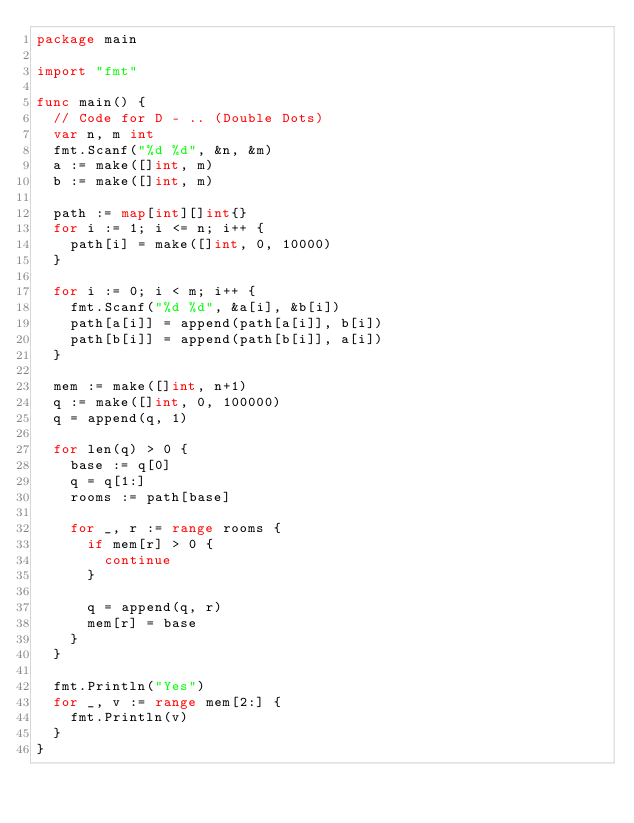Convert code to text. <code><loc_0><loc_0><loc_500><loc_500><_Go_>package main

import "fmt"

func main() {
	// Code for D - .. (Double Dots)
	var n, m int
	fmt.Scanf("%d %d", &n, &m)
	a := make([]int, m)
	b := make([]int, m)

	path := map[int][]int{}
	for i := 1; i <= n; i++ {
		path[i] = make([]int, 0, 10000)
	}

	for i := 0; i < m; i++ {
		fmt.Scanf("%d %d", &a[i], &b[i])
		path[a[i]] = append(path[a[i]], b[i])
		path[b[i]] = append(path[b[i]], a[i])
	}

	mem := make([]int, n+1)
	q := make([]int, 0, 100000)
	q = append(q, 1)

	for len(q) > 0 {
		base := q[0]
		q = q[1:]
		rooms := path[base]

		for _, r := range rooms {
			if mem[r] > 0 {
				continue
			}

			q = append(q, r)
			mem[r] = base
		}
	}

	fmt.Println("Yes")
	for _, v := range mem[2:] {
		fmt.Println(v)
	}
}</code> 